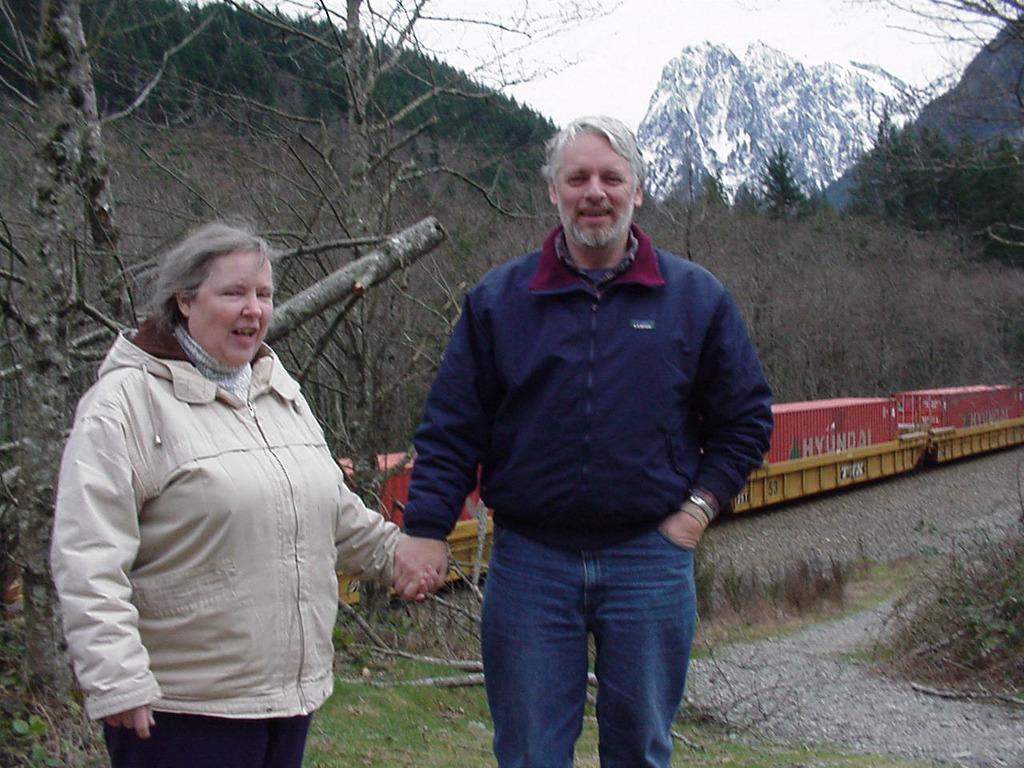How would you summarize this image in a sentence or two? In this image I can see a woman and man and they both are smiling and standing on the ground ,back side of them I can see the hill, tree and grass and I can see a red color train visible in the middle. 